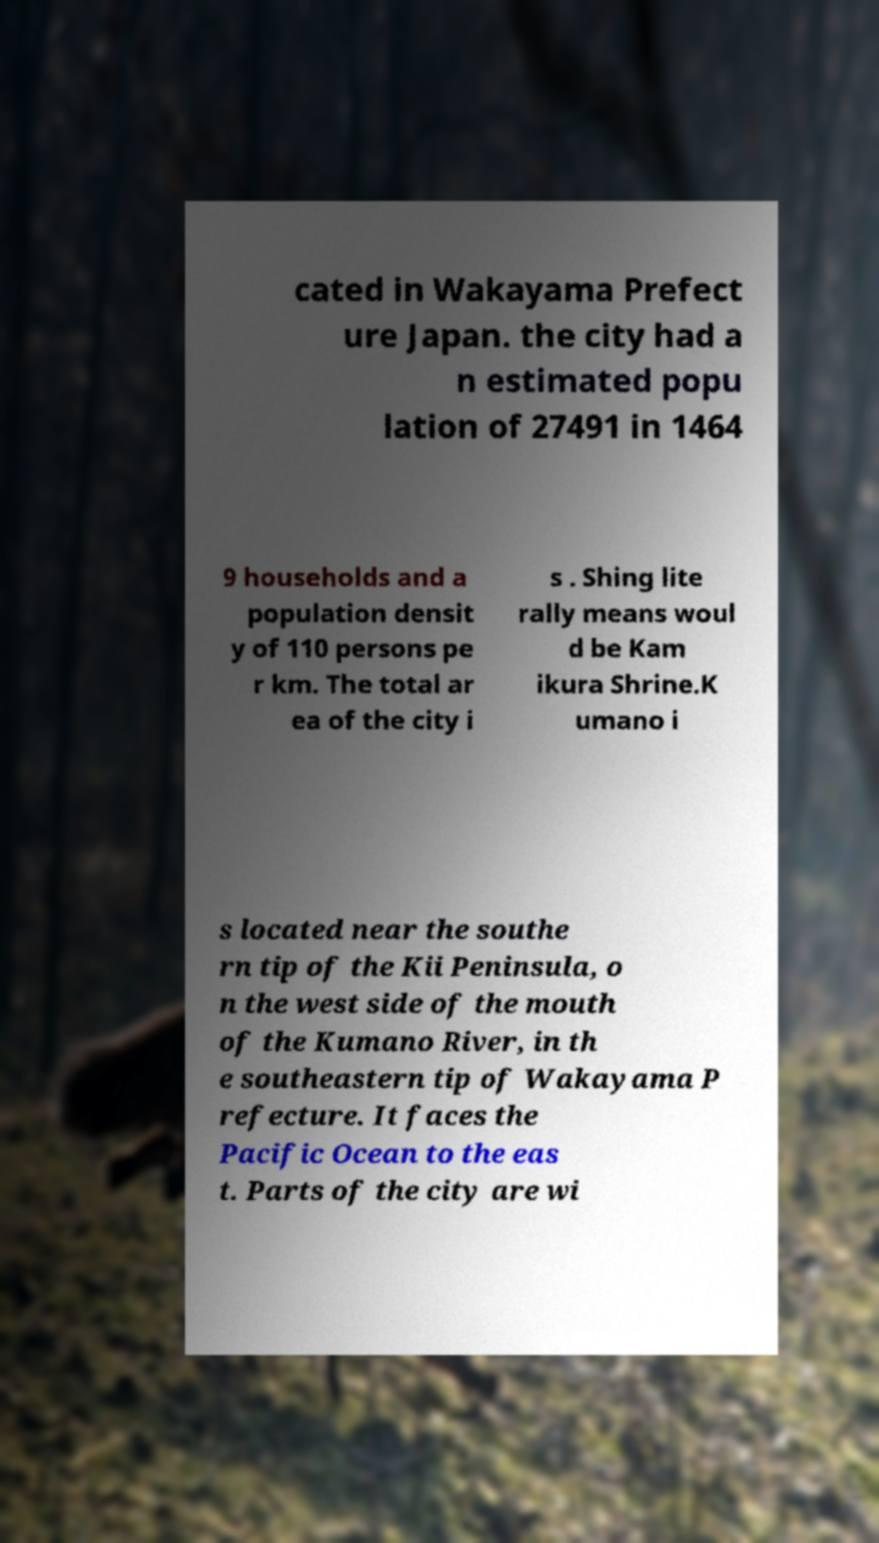There's text embedded in this image that I need extracted. Can you transcribe it verbatim? cated in Wakayama Prefect ure Japan. the city had a n estimated popu lation of 27491 in 1464 9 households and a population densit y of 110 persons pe r km. The total ar ea of the city i s . Shing lite rally means woul d be Kam ikura Shrine.K umano i s located near the southe rn tip of the Kii Peninsula, o n the west side of the mouth of the Kumano River, in th e southeastern tip of Wakayama P refecture. It faces the Pacific Ocean to the eas t. Parts of the city are wi 